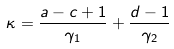Convert formula to latex. <formula><loc_0><loc_0><loc_500><loc_500>\kappa = \frac { a - c + 1 } { \gamma _ { 1 } } + \frac { d - 1 } { \gamma _ { 2 } }</formula> 